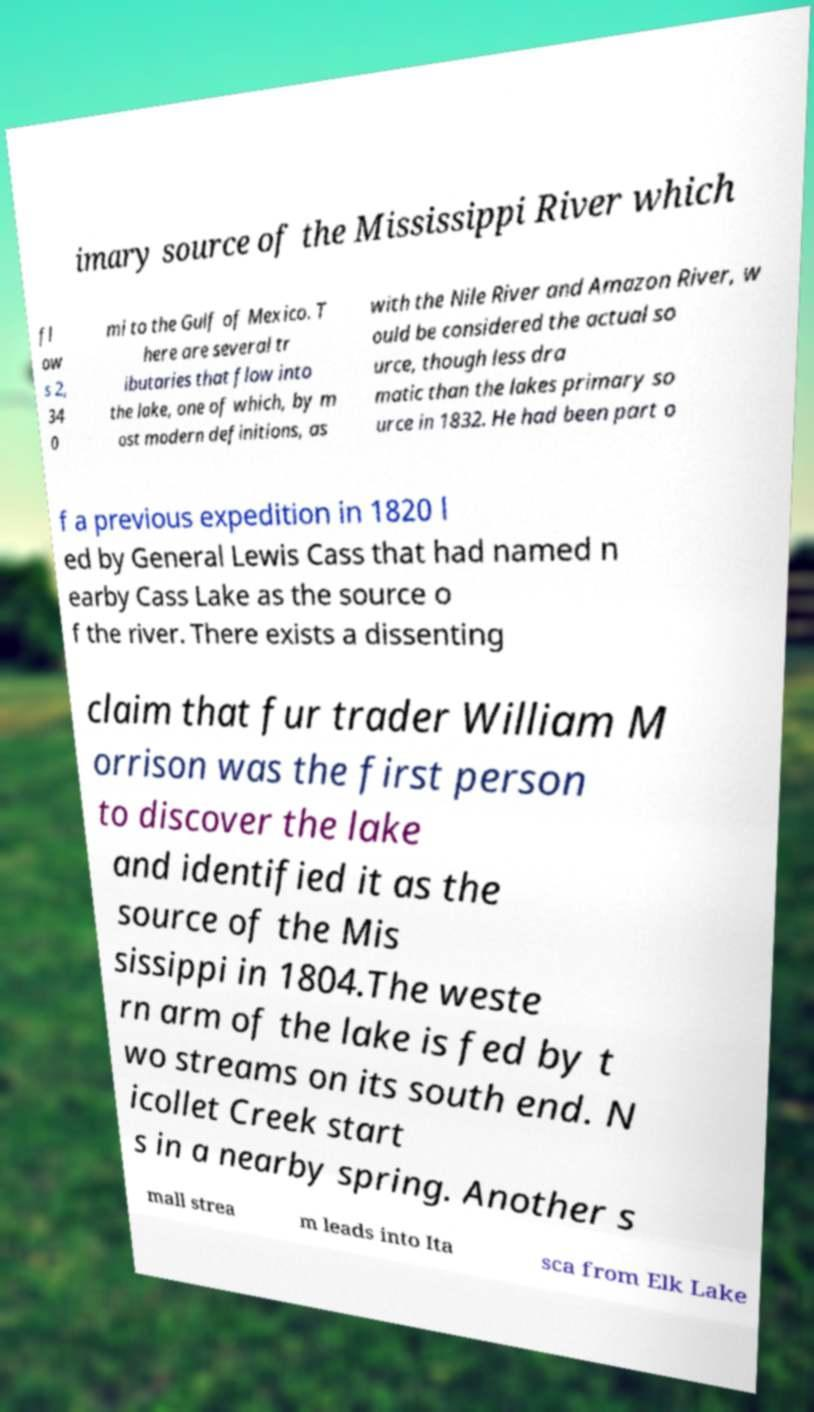Can you accurately transcribe the text from the provided image for me? imary source of the Mississippi River which fl ow s 2, 34 0 mi to the Gulf of Mexico. T here are several tr ibutaries that flow into the lake, one of which, by m ost modern definitions, as with the Nile River and Amazon River, w ould be considered the actual so urce, though less dra matic than the lakes primary so urce in 1832. He had been part o f a previous expedition in 1820 l ed by General Lewis Cass that had named n earby Cass Lake as the source o f the river. There exists a dissenting claim that fur trader William M orrison was the first person to discover the lake and identified it as the source of the Mis sissippi in 1804.The weste rn arm of the lake is fed by t wo streams on its south end. N icollet Creek start s in a nearby spring. Another s mall strea m leads into Ita sca from Elk Lake 